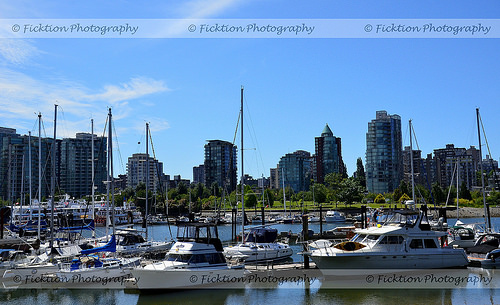<image>
Is the boat in front of the building? Yes. The boat is positioned in front of the building, appearing closer to the camera viewpoint. Is there a boat in front of the building? Yes. The boat is positioned in front of the building, appearing closer to the camera viewpoint. 